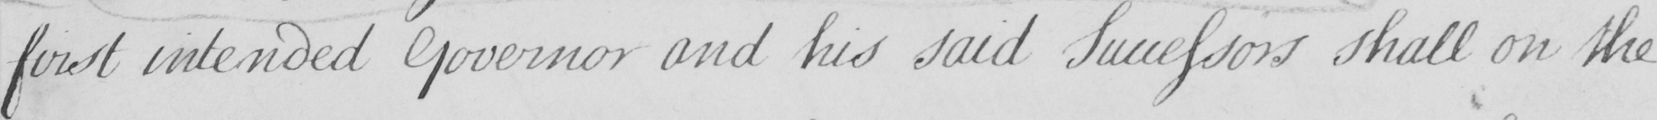What text is written in this handwritten line? first intended Governor and his said Successors shall on the 